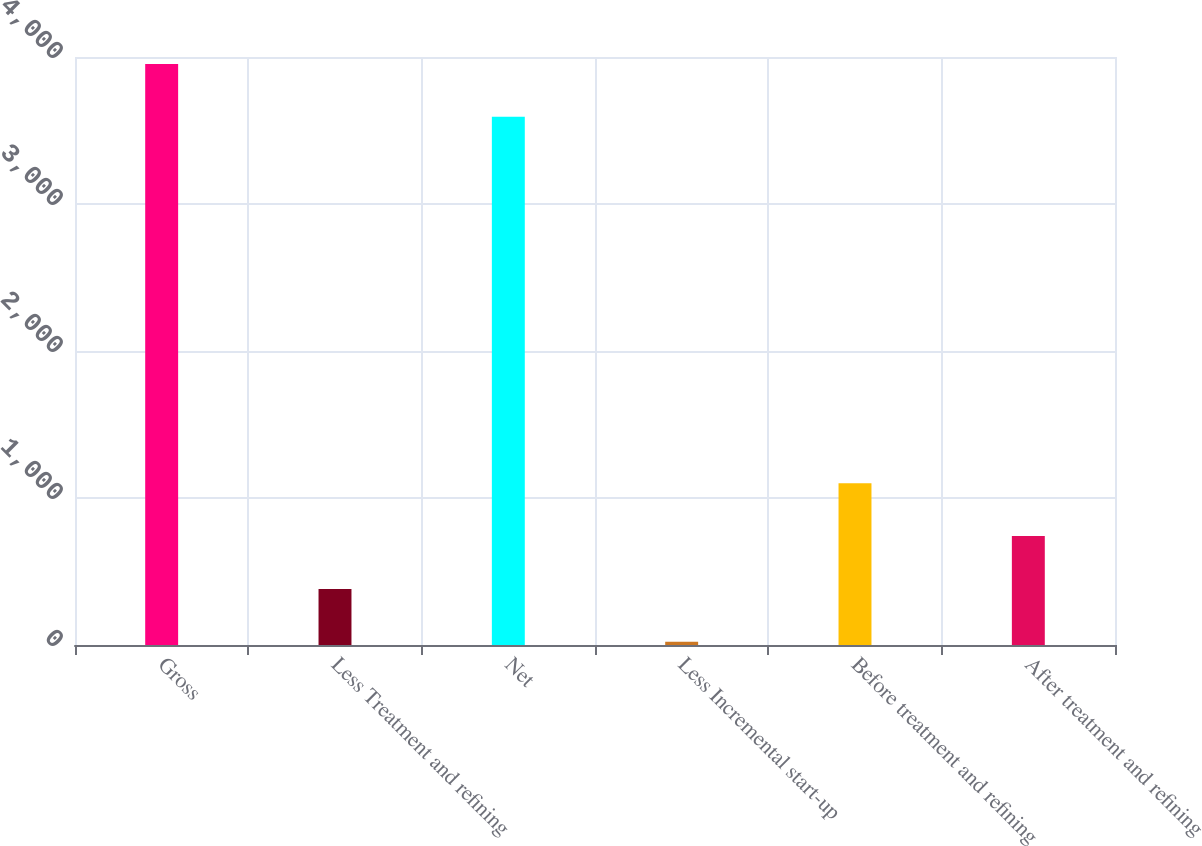Convert chart to OTSL. <chart><loc_0><loc_0><loc_500><loc_500><bar_chart><fcel>Gross<fcel>Less Treatment and refining<fcel>Net<fcel>Less Incremental start-up<fcel>Before treatment and refining<fcel>After treatment and refining<nl><fcel>3952.7<fcel>381.7<fcel>3593<fcel>22<fcel>1101.1<fcel>741.4<nl></chart> 